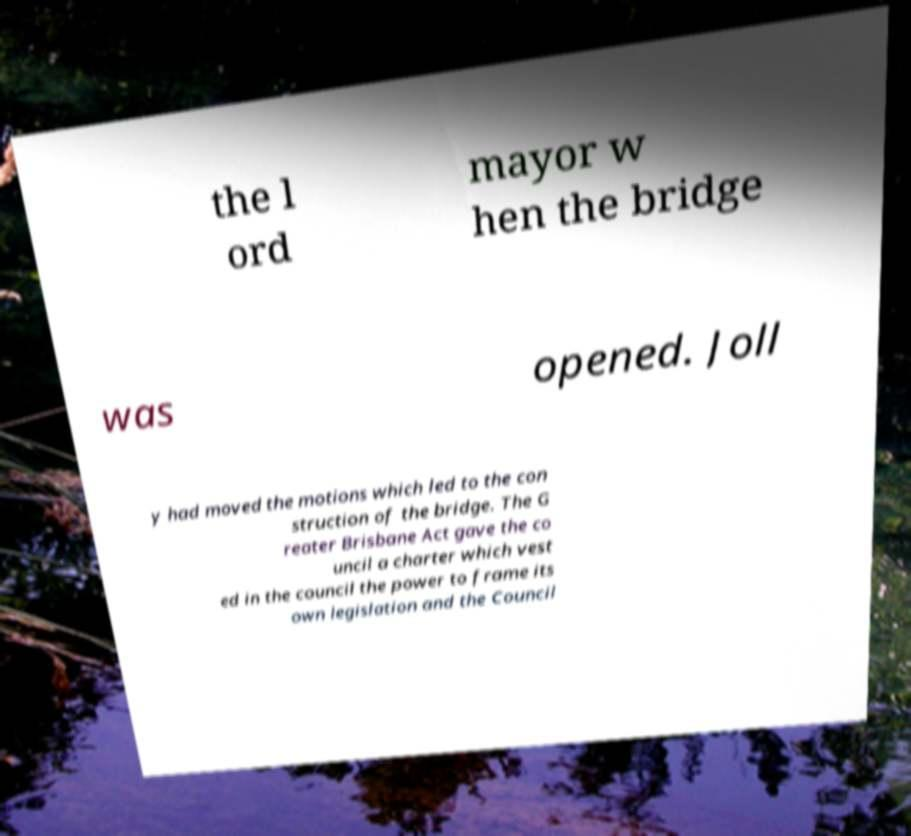Can you accurately transcribe the text from the provided image for me? the l ord mayor w hen the bridge was opened. Joll y had moved the motions which led to the con struction of the bridge. The G reater Brisbane Act gave the co uncil a charter which vest ed in the council the power to frame its own legislation and the Council 